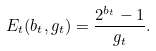Convert formula to latex. <formula><loc_0><loc_0><loc_500><loc_500>E _ { t } ( b _ { t } , g _ { t } ) = \frac { 2 ^ { b _ { t } } - 1 } { g _ { t } } .</formula> 